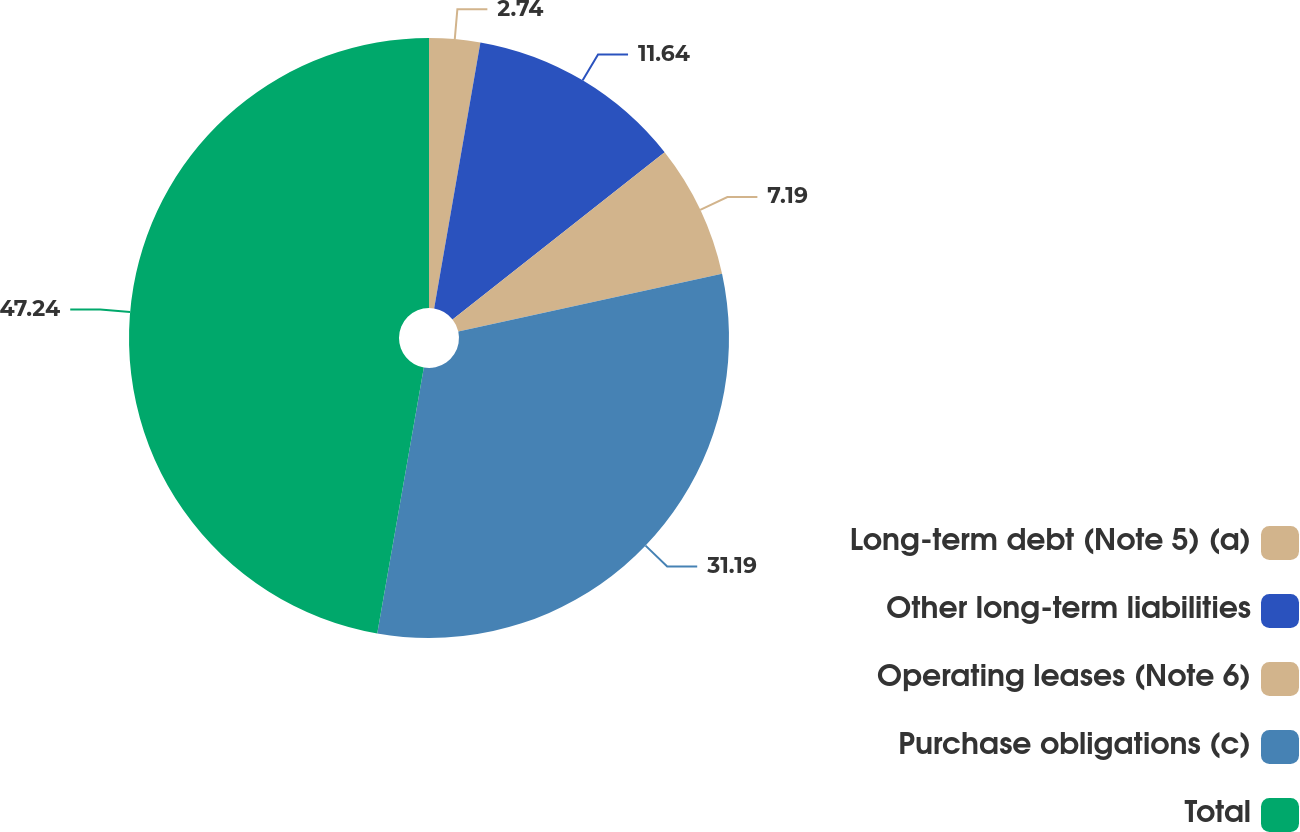Convert chart to OTSL. <chart><loc_0><loc_0><loc_500><loc_500><pie_chart><fcel>Long-term debt (Note 5) (a)<fcel>Other long-term liabilities<fcel>Operating leases (Note 6)<fcel>Purchase obligations (c)<fcel>Total<nl><fcel>2.74%<fcel>11.64%<fcel>7.19%<fcel>31.19%<fcel>47.24%<nl></chart> 